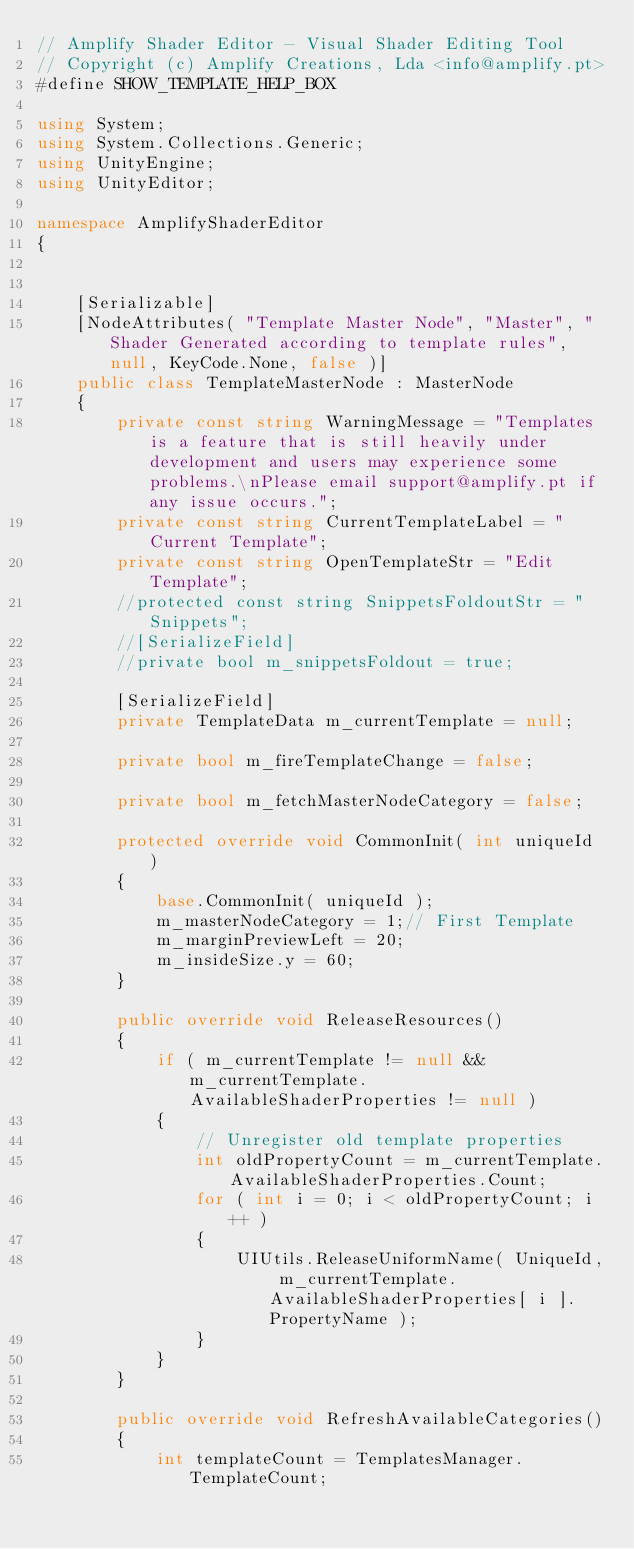Convert code to text. <code><loc_0><loc_0><loc_500><loc_500><_C#_>// Amplify Shader Editor - Visual Shader Editing Tool
// Copyright (c) Amplify Creations, Lda <info@amplify.pt>
#define SHOW_TEMPLATE_HELP_BOX

using System;
using System.Collections.Generic;
using UnityEngine;
using UnityEditor;

namespace AmplifyShaderEditor
{
	

	[Serializable]
	[NodeAttributes( "Template Master Node", "Master", "Shader Generated according to template rules", null, KeyCode.None, false )]
	public class TemplateMasterNode : MasterNode
	{
		private const string WarningMessage = "Templates is a feature that is still heavily under development and users may experience some problems.\nPlease email support@amplify.pt if any issue occurs.";
		private const string CurrentTemplateLabel = "Current Template";
		private const string OpenTemplateStr = "Edit Template";
		//protected const string SnippetsFoldoutStr = " Snippets";
		//[SerializeField]
		//private bool m_snippetsFoldout = true;

		[SerializeField]
		private TemplateData m_currentTemplate = null;

		private bool m_fireTemplateChange = false;

		private bool m_fetchMasterNodeCategory = false;

		protected override void CommonInit( int uniqueId )
		{
			base.CommonInit( uniqueId );
			m_masterNodeCategory = 1;// First Template
			m_marginPreviewLeft = 20;
			m_insideSize.y = 60;
		}

		public override void ReleaseResources()
		{
			if ( m_currentTemplate != null && m_currentTemplate.AvailableShaderProperties != null )
			{
				// Unregister old template properties
				int oldPropertyCount = m_currentTemplate.AvailableShaderProperties.Count;
				for ( int i = 0; i < oldPropertyCount; i++ )
				{
					UIUtils.ReleaseUniformName( UniqueId, m_currentTemplate.AvailableShaderProperties[ i ].PropertyName );
				}
			}
		}

		public override void RefreshAvailableCategories()
		{
			int templateCount = TemplatesManager.TemplateCount;</code> 